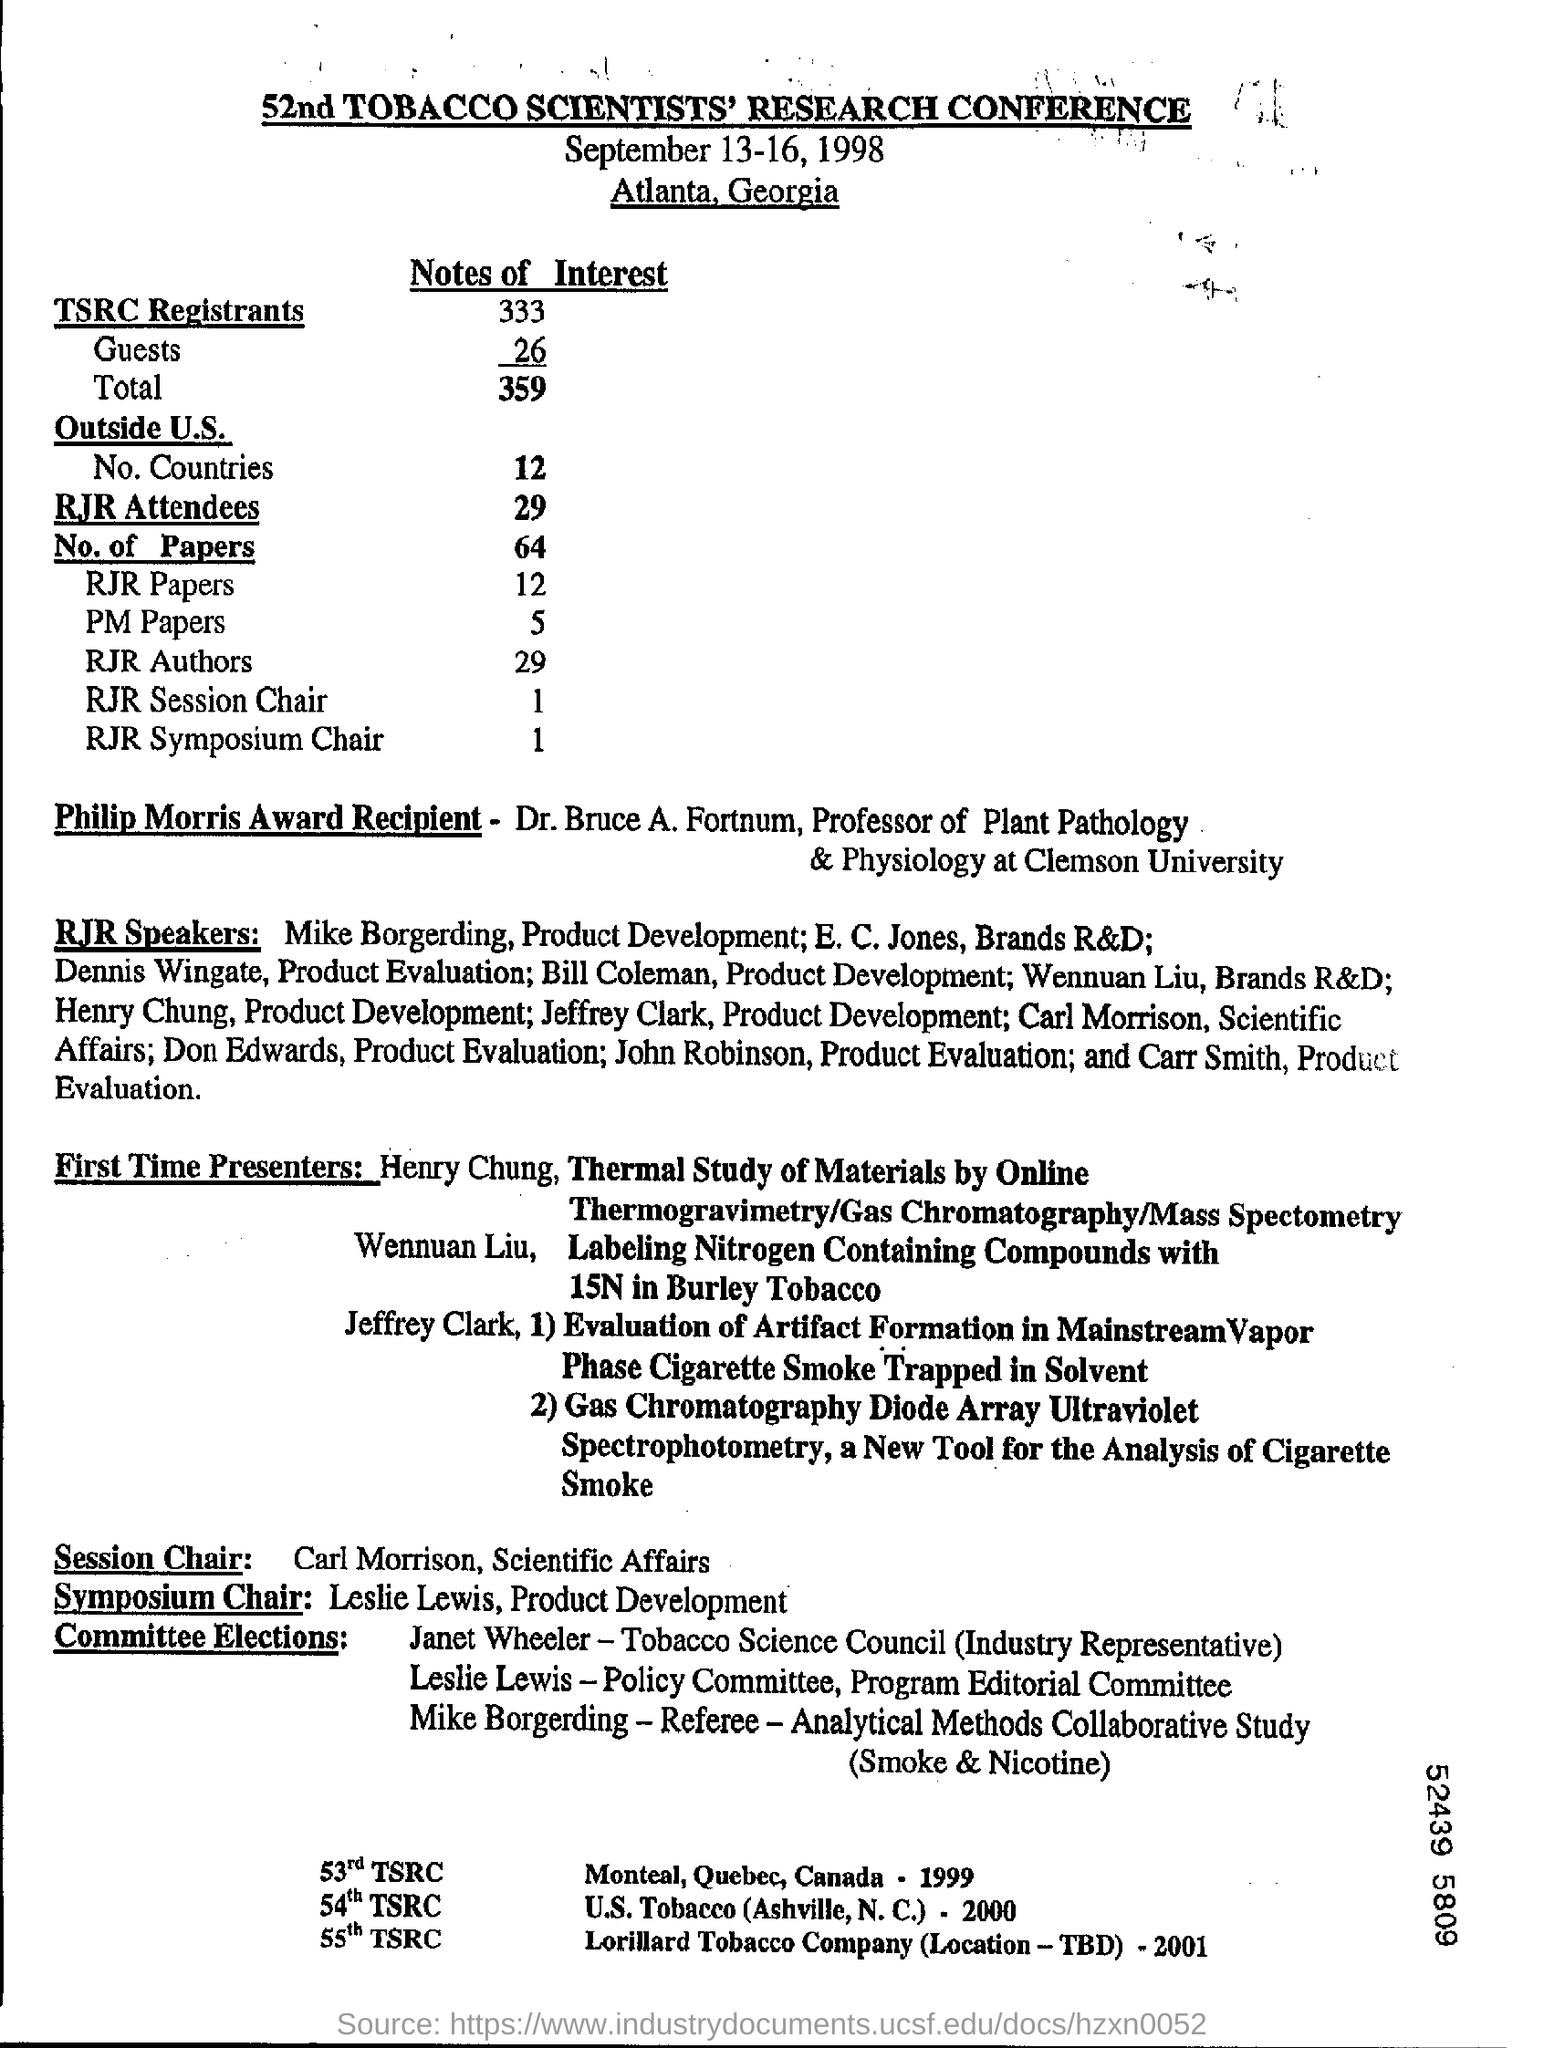Give some essential details in this illustration. There is one RJR Symposium Chair mentioned. The heading of the document is the 52nd TOBACCO SCIENTISTS' RESEARCH CONFERENCE. There are 26 guests mentioned. The conference is located in Atlanta, Georgia. The Session Chair includes Carl Morrison, who is responsible for scientific affairs. 